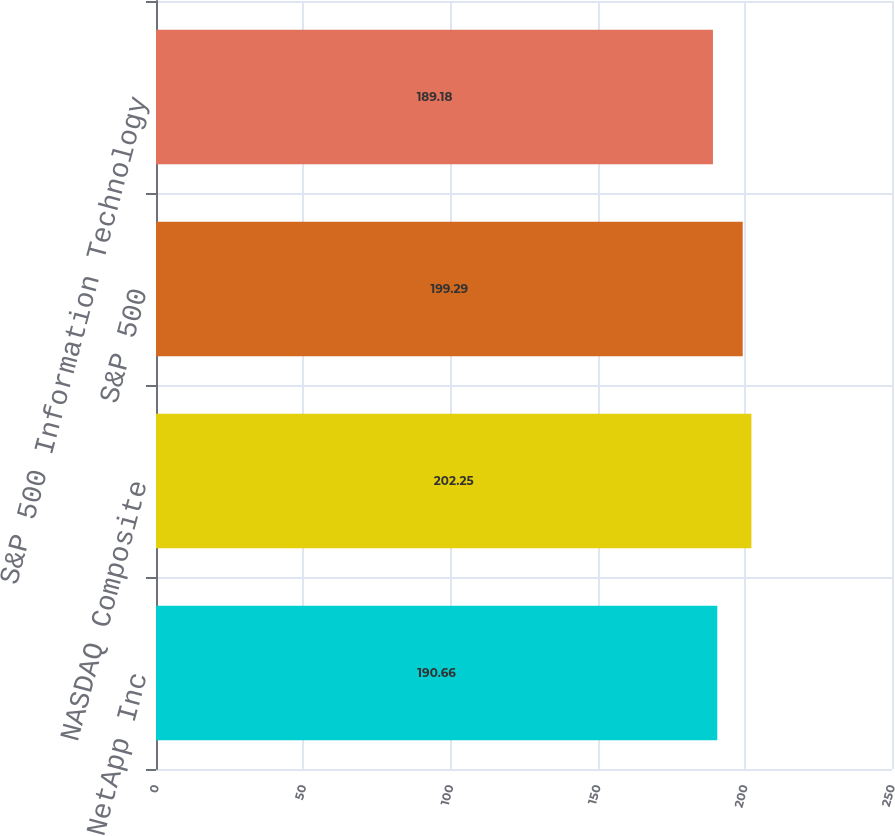Convert chart. <chart><loc_0><loc_0><loc_500><loc_500><bar_chart><fcel>NetApp Inc<fcel>NASDAQ Composite<fcel>S&P 500<fcel>S&P 500 Information Technology<nl><fcel>190.66<fcel>202.25<fcel>199.29<fcel>189.18<nl></chart> 